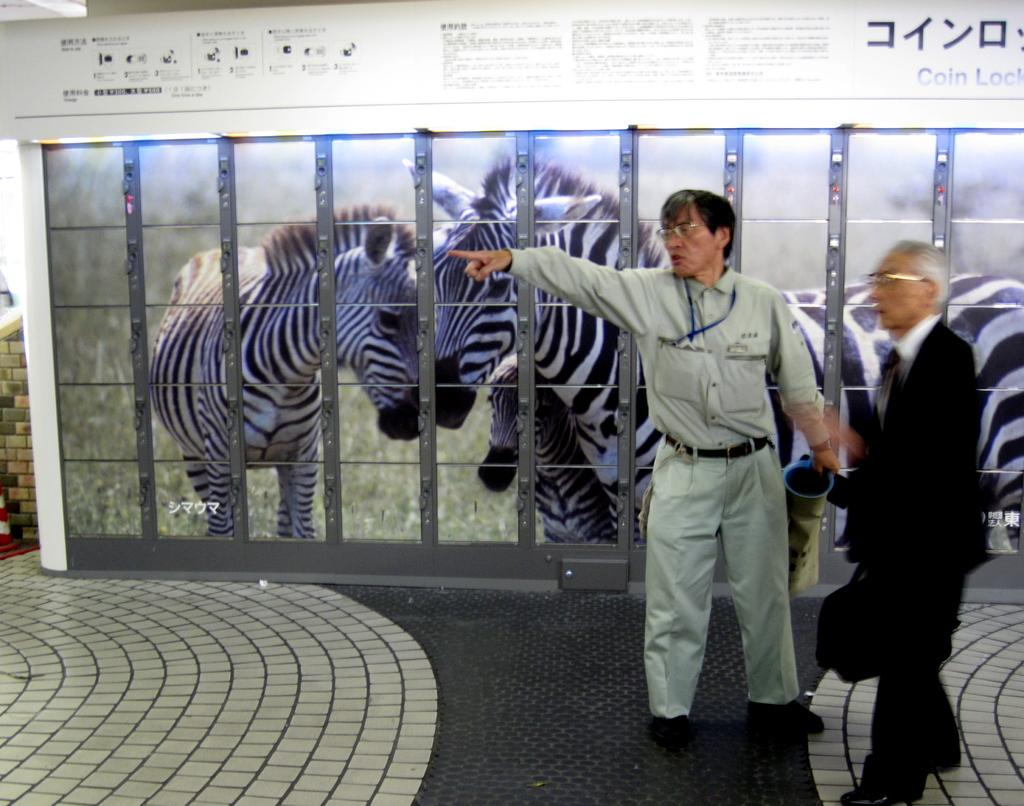How many people are in the image? There are two people standing in the foreground of the image. What can be seen in the background of the image? There is a poster of zebras in the background of the image. What is visible at the bottom of the image? There is a floor visible at the bottom of the image. Where is the throne located in the image? There is no throne present in the image. How many geese are flying in the image? There are no geese present in the image. 